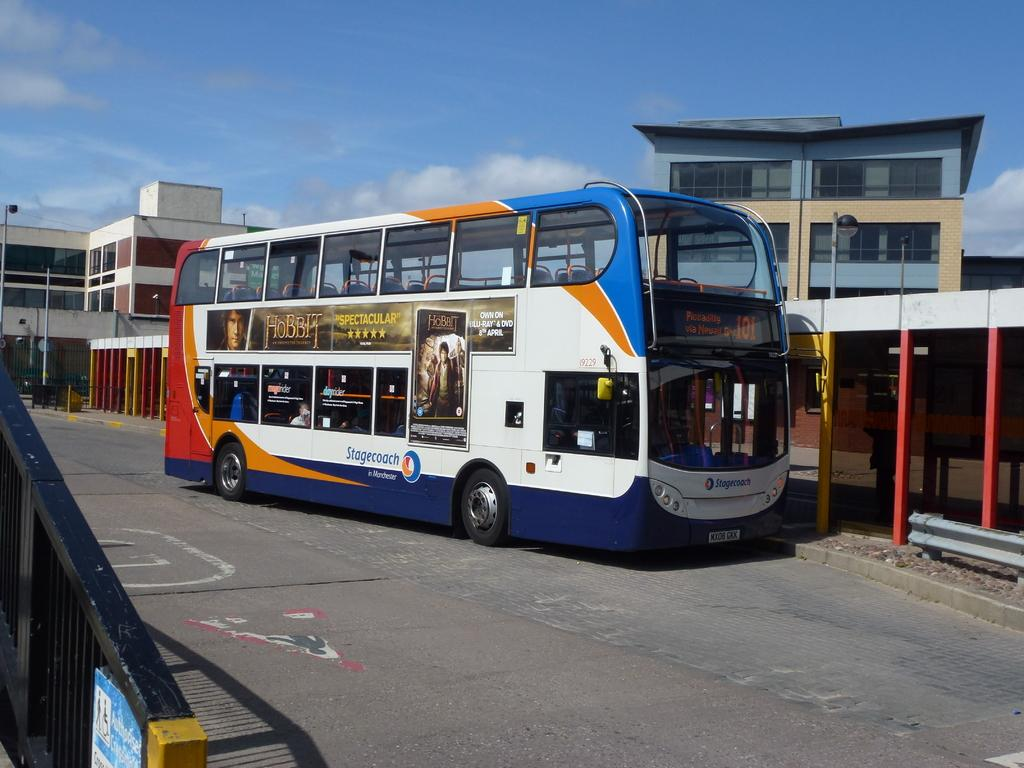What type of structures can be seen in the image? There are buildings in the image. What else can be seen on the ground in the image? There is a vehicle on the road in the image. What is visible in the background of the image? The sky is visible in the background of the image. How many baskets of wealth are visible in the image? There are no baskets of wealth present in the image. What type of dolls can be seen playing in the image? There are no dolls present in the image. 